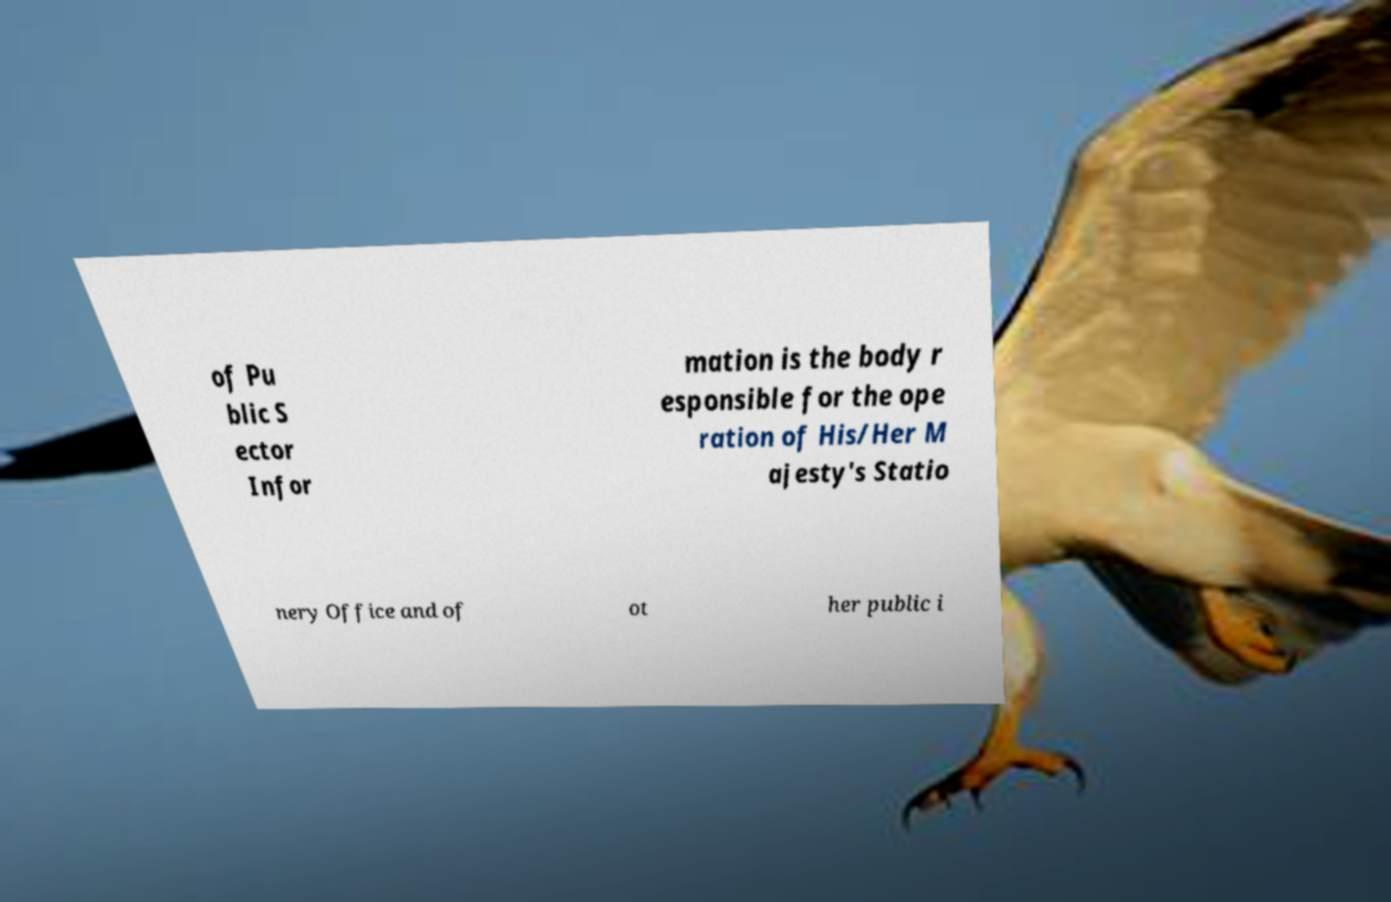For documentation purposes, I need the text within this image transcribed. Could you provide that? of Pu blic S ector Infor mation is the body r esponsible for the ope ration of His/Her M ajesty's Statio nery Office and of ot her public i 